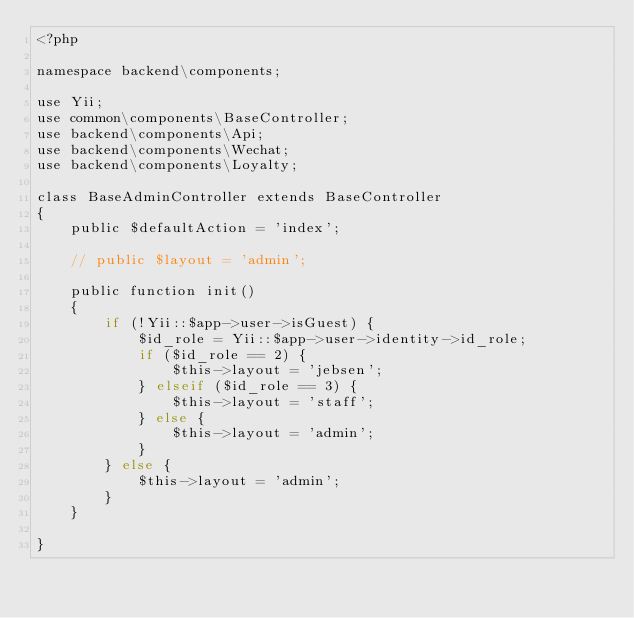Convert code to text. <code><loc_0><loc_0><loc_500><loc_500><_PHP_><?php

namespace backend\components;

use Yii;
use common\components\BaseController;
use backend\components\Api;
use backend\components\Wechat;
use backend\components\Loyalty;

class BaseAdminController extends BaseController
{
    public $defaultAction = 'index';

    // public $layout = 'admin';

    public function init()
    {
        if (!Yii::$app->user->isGuest) {
            $id_role = Yii::$app->user->identity->id_role;
            if ($id_role == 2) {
                $this->layout = 'jebsen';
            } elseif ($id_role == 3) {
                $this->layout = 'staff';
            } else {
                $this->layout = 'admin';
            }
        } else {
            $this->layout = 'admin';
        }
    }

}
</code> 